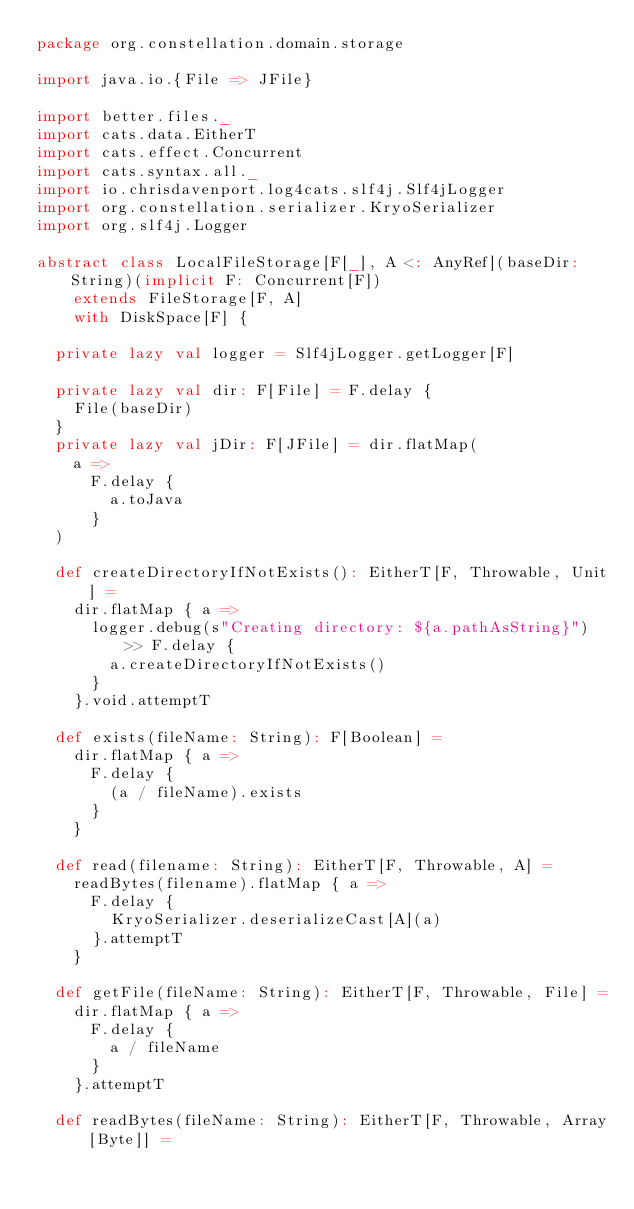<code> <loc_0><loc_0><loc_500><loc_500><_Scala_>package org.constellation.domain.storage

import java.io.{File => JFile}

import better.files._
import cats.data.EitherT
import cats.effect.Concurrent
import cats.syntax.all._
import io.chrisdavenport.log4cats.slf4j.Slf4jLogger
import org.constellation.serializer.KryoSerializer
import org.slf4j.Logger

abstract class LocalFileStorage[F[_], A <: AnyRef](baseDir: String)(implicit F: Concurrent[F])
    extends FileStorage[F, A]
    with DiskSpace[F] {

  private lazy val logger = Slf4jLogger.getLogger[F]

  private lazy val dir: F[File] = F.delay {
    File(baseDir)
  }
  private lazy val jDir: F[JFile] = dir.flatMap(
    a =>
      F.delay {
        a.toJava
      }
  )

  def createDirectoryIfNotExists(): EitherT[F, Throwable, Unit] =
    dir.flatMap { a =>
      logger.debug(s"Creating directory: ${a.pathAsString}") >> F.delay {
        a.createDirectoryIfNotExists()
      }
    }.void.attemptT

  def exists(fileName: String): F[Boolean] =
    dir.flatMap { a =>
      F.delay {
        (a / fileName).exists
      }
    }

  def read(filename: String): EitherT[F, Throwable, A] =
    readBytes(filename).flatMap { a =>
      F.delay {
        KryoSerializer.deserializeCast[A](a)
      }.attemptT
    }

  def getFile(fileName: String): EitherT[F, Throwable, File] =
    dir.flatMap { a =>
      F.delay {
        a / fileName
      }
    }.attemptT

  def readBytes(fileName: String): EitherT[F, Throwable, Array[Byte]] =</code> 